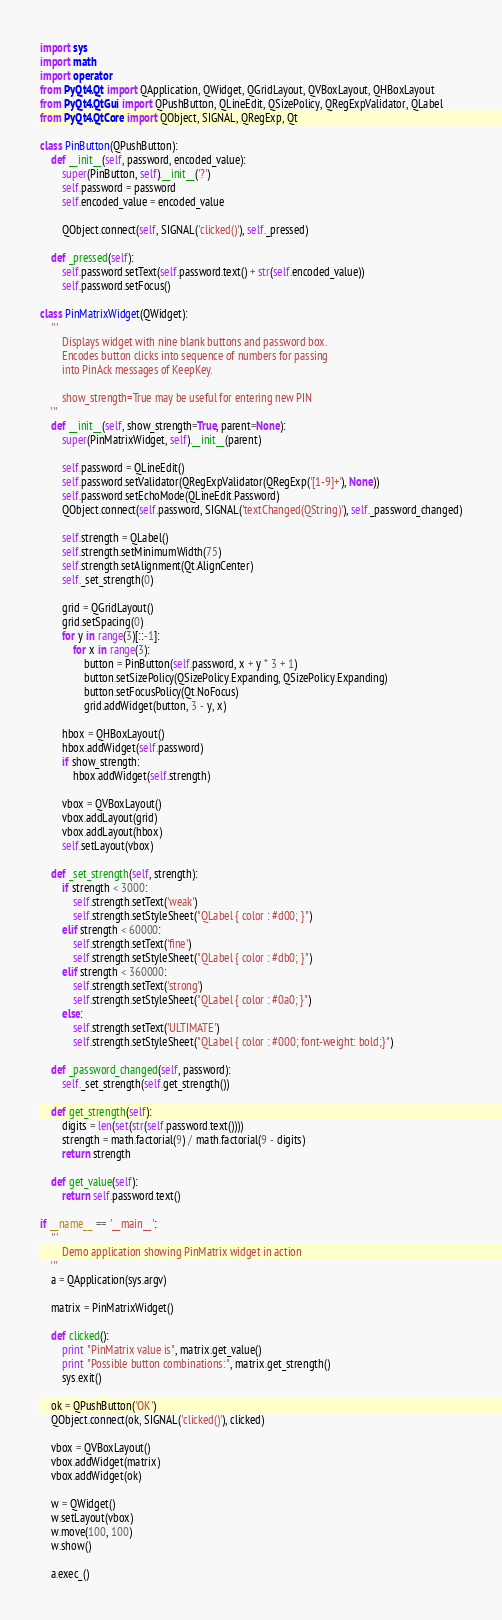Convert code to text. <code><loc_0><loc_0><loc_500><loc_500><_Python_>import sys
import math
import operator
from PyQt4.Qt import QApplication, QWidget, QGridLayout, QVBoxLayout, QHBoxLayout
from PyQt4.QtGui import QPushButton, QLineEdit, QSizePolicy, QRegExpValidator, QLabel
from PyQt4.QtCore import QObject, SIGNAL, QRegExp, Qt

class PinButton(QPushButton):
    def __init__(self, password, encoded_value):
        super(PinButton, self).__init__('?')
        self.password = password
        self.encoded_value = encoded_value

        QObject.connect(self, SIGNAL('clicked()'), self._pressed)

    def _pressed(self):
        self.password.setText(self.password.text() + str(self.encoded_value))
        self.password.setFocus()

class PinMatrixWidget(QWidget):
    '''
        Displays widget with nine blank buttons and password box.
        Encodes button clicks into sequence of numbers for passing
        into PinAck messages of KeepKey.

        show_strength=True may be useful for entering new PIN
    '''
    def __init__(self, show_strength=True, parent=None):
        super(PinMatrixWidget, self).__init__(parent)
        
        self.password = QLineEdit()
        self.password.setValidator(QRegExpValidator(QRegExp('[1-9]+'), None))
        self.password.setEchoMode(QLineEdit.Password)
        QObject.connect(self.password, SIGNAL('textChanged(QString)'), self._password_changed)

        self.strength = QLabel()
        self.strength.setMinimumWidth(75)
        self.strength.setAlignment(Qt.AlignCenter)
        self._set_strength(0)

        grid = QGridLayout()
        grid.setSpacing(0)
        for y in range(3)[::-1]:
            for x in range(3):
                button = PinButton(self.password, x + y * 3 + 1)
                button.setSizePolicy(QSizePolicy.Expanding, QSizePolicy.Expanding)
                button.setFocusPolicy(Qt.NoFocus)
                grid.addWidget(button, 3 - y, x)

        hbox = QHBoxLayout()
        hbox.addWidget(self.password)
        if show_strength:
            hbox.addWidget(self.strength)

        vbox = QVBoxLayout()
        vbox.addLayout(grid)
        vbox.addLayout(hbox)
        self.setLayout(vbox)

    def _set_strength(self, strength):
        if strength < 3000:
            self.strength.setText('weak')
            self.strength.setStyleSheet("QLabel { color : #d00; }")
        elif strength < 60000:
            self.strength.setText('fine')
            self.strength.setStyleSheet("QLabel { color : #db0; }")
        elif strength < 360000:
            self.strength.setText('strong')
            self.strength.setStyleSheet("QLabel { color : #0a0; }")
        else:
            self.strength.setText('ULTIMATE')
            self.strength.setStyleSheet("QLabel { color : #000; font-weight: bold;}")

    def _password_changed(self, password):
        self._set_strength(self.get_strength())

    def get_strength(self):
        digits = len(set(str(self.password.text())))
        strength = math.factorial(9) / math.factorial(9 - digits)
        return strength

    def get_value(self):
        return self.password.text()

if __name__ == '__main__':
    '''
        Demo application showing PinMatrix widget in action
    '''
    a = QApplication(sys.argv)

    matrix = PinMatrixWidget()

    def clicked():
        print "PinMatrix value is", matrix.get_value()
        print "Possible button combinations:", matrix.get_strength()
        sys.exit()

    ok = QPushButton('OK')
    QObject.connect(ok, SIGNAL('clicked()'), clicked)

    vbox = QVBoxLayout()
    vbox.addWidget(matrix)
    vbox.addWidget(ok)

    w = QWidget()
    w.setLayout(vbox)
    w.move(100, 100)
    w.show()

    a.exec_()
</code> 